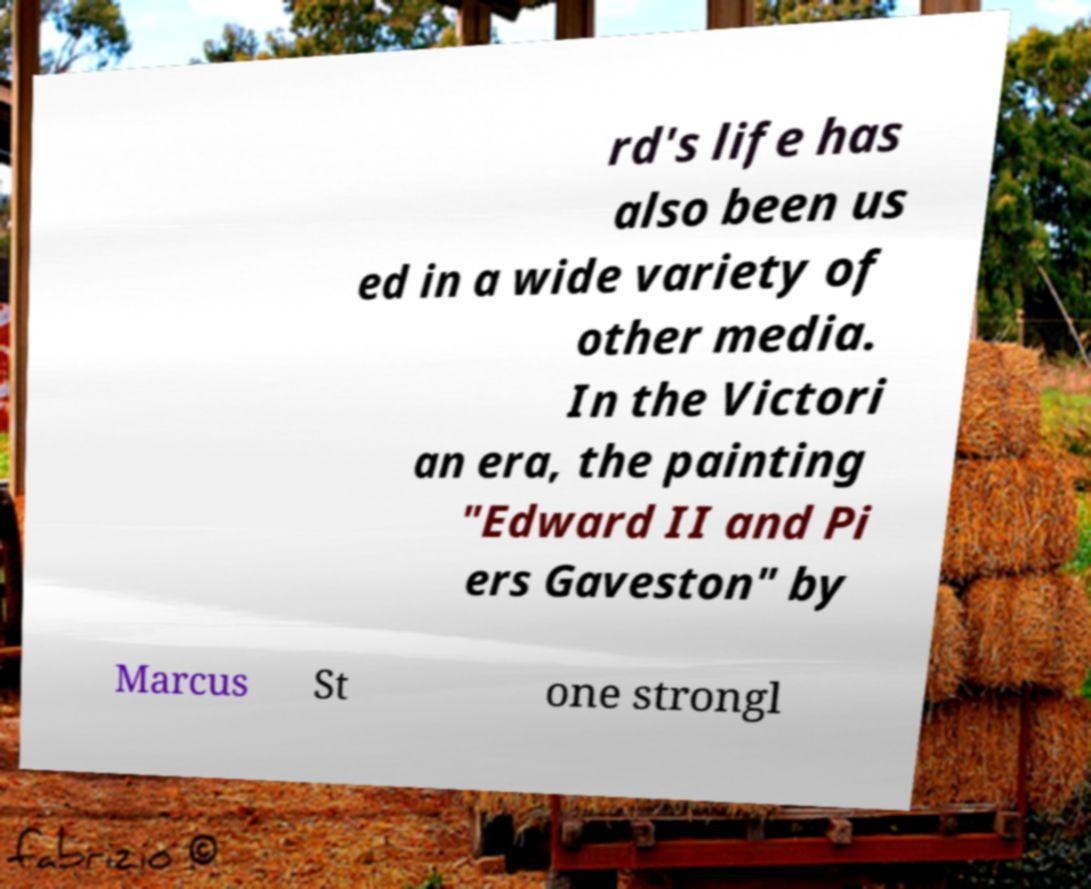Please identify and transcribe the text found in this image. rd's life has also been us ed in a wide variety of other media. In the Victori an era, the painting "Edward II and Pi ers Gaveston" by Marcus St one strongl 